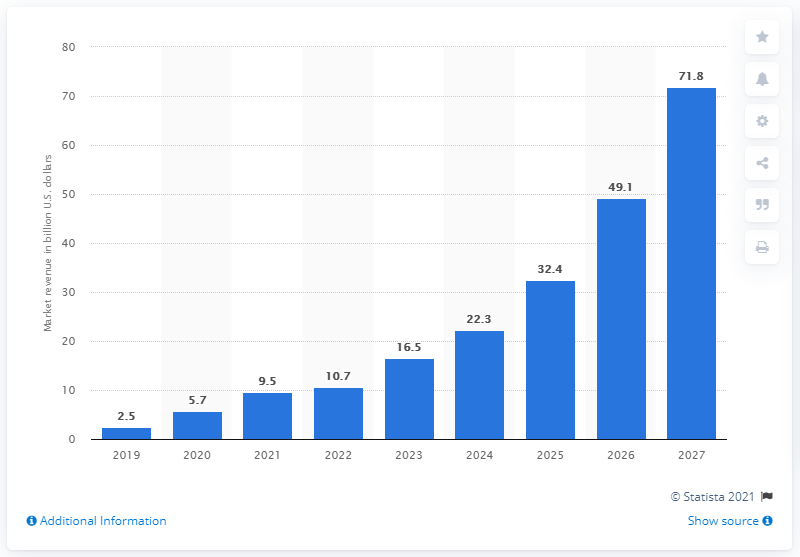Outline some significant characteristics in this image. The global market for micro-LED displays is expected to reach approximately 71.8% by the year 2027. 